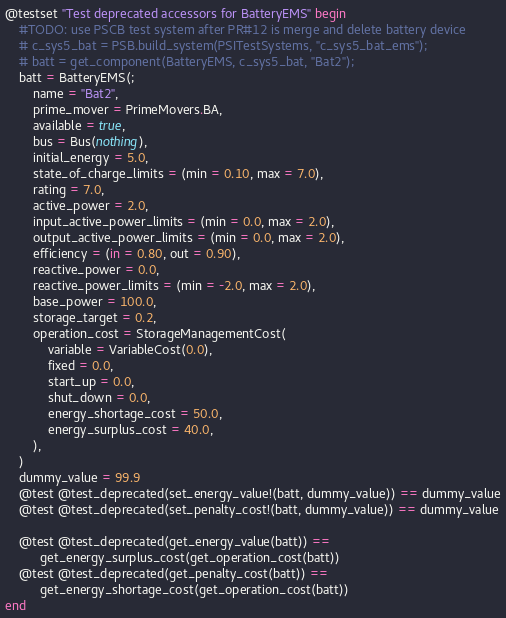<code> <loc_0><loc_0><loc_500><loc_500><_Julia_>@testset "Test deprecated accessors for BatteryEMS" begin
    #TODO: use PSCB test system after PR#12 is merge and delete battery device
    # c_sys5_bat = PSB.build_system(PSITestSystems, "c_sys5_bat_ems");
    # batt = get_component(BatteryEMS, c_sys5_bat, "Bat2");
    batt = BatteryEMS(;
        name = "Bat2",
        prime_mover = PrimeMovers.BA,
        available = true,
        bus = Bus(nothing),
        initial_energy = 5.0,
        state_of_charge_limits = (min = 0.10, max = 7.0),
        rating = 7.0,
        active_power = 2.0,
        input_active_power_limits = (min = 0.0, max = 2.0),
        output_active_power_limits = (min = 0.0, max = 2.0),
        efficiency = (in = 0.80, out = 0.90),
        reactive_power = 0.0,
        reactive_power_limits = (min = -2.0, max = 2.0),
        base_power = 100.0,
        storage_target = 0.2,
        operation_cost = StorageManagementCost(
            variable = VariableCost(0.0),
            fixed = 0.0,
            start_up = 0.0,
            shut_down = 0.0,
            energy_shortage_cost = 50.0,
            energy_surplus_cost = 40.0,
        ),
    )
    dummy_value = 99.9
    @test @test_deprecated(set_energy_value!(batt, dummy_value)) == dummy_value
    @test @test_deprecated(set_penalty_cost!(batt, dummy_value)) == dummy_value

    @test @test_deprecated(get_energy_value(batt)) ==
          get_energy_surplus_cost(get_operation_cost(batt))
    @test @test_deprecated(get_penalty_cost(batt)) ==
          get_energy_shortage_cost(get_operation_cost(batt))
end
</code> 